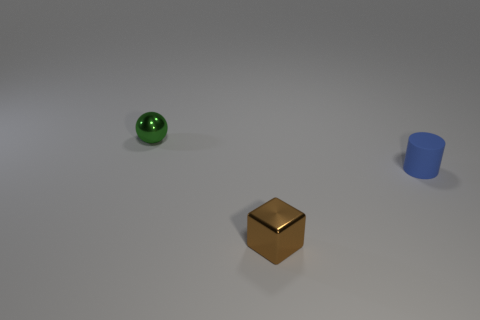Subtract all gray cylinders. Subtract all yellow cubes. How many cylinders are left? 1 Add 3 big brown things. How many objects exist? 6 Subtract all balls. How many objects are left? 2 Subtract 1 brown blocks. How many objects are left? 2 Subtract all brown metallic cubes. Subtract all small brown blocks. How many objects are left? 1 Add 1 small blue things. How many small blue things are left? 2 Add 1 shiny balls. How many shiny balls exist? 2 